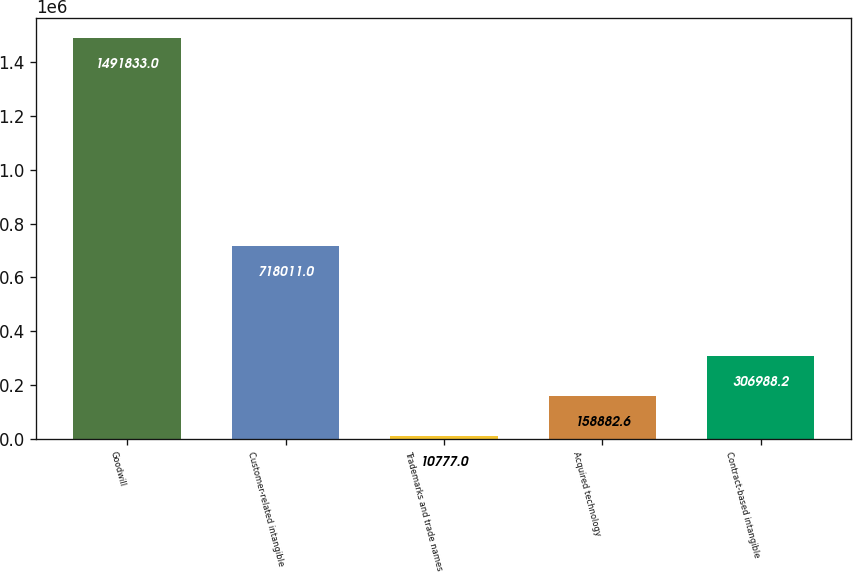Convert chart to OTSL. <chart><loc_0><loc_0><loc_500><loc_500><bar_chart><fcel>Goodwill<fcel>Customer-related intangible<fcel>Trademarks and trade names<fcel>Acquired technology<fcel>Contract-based intangible<nl><fcel>1.49183e+06<fcel>718011<fcel>10777<fcel>158883<fcel>306988<nl></chart> 